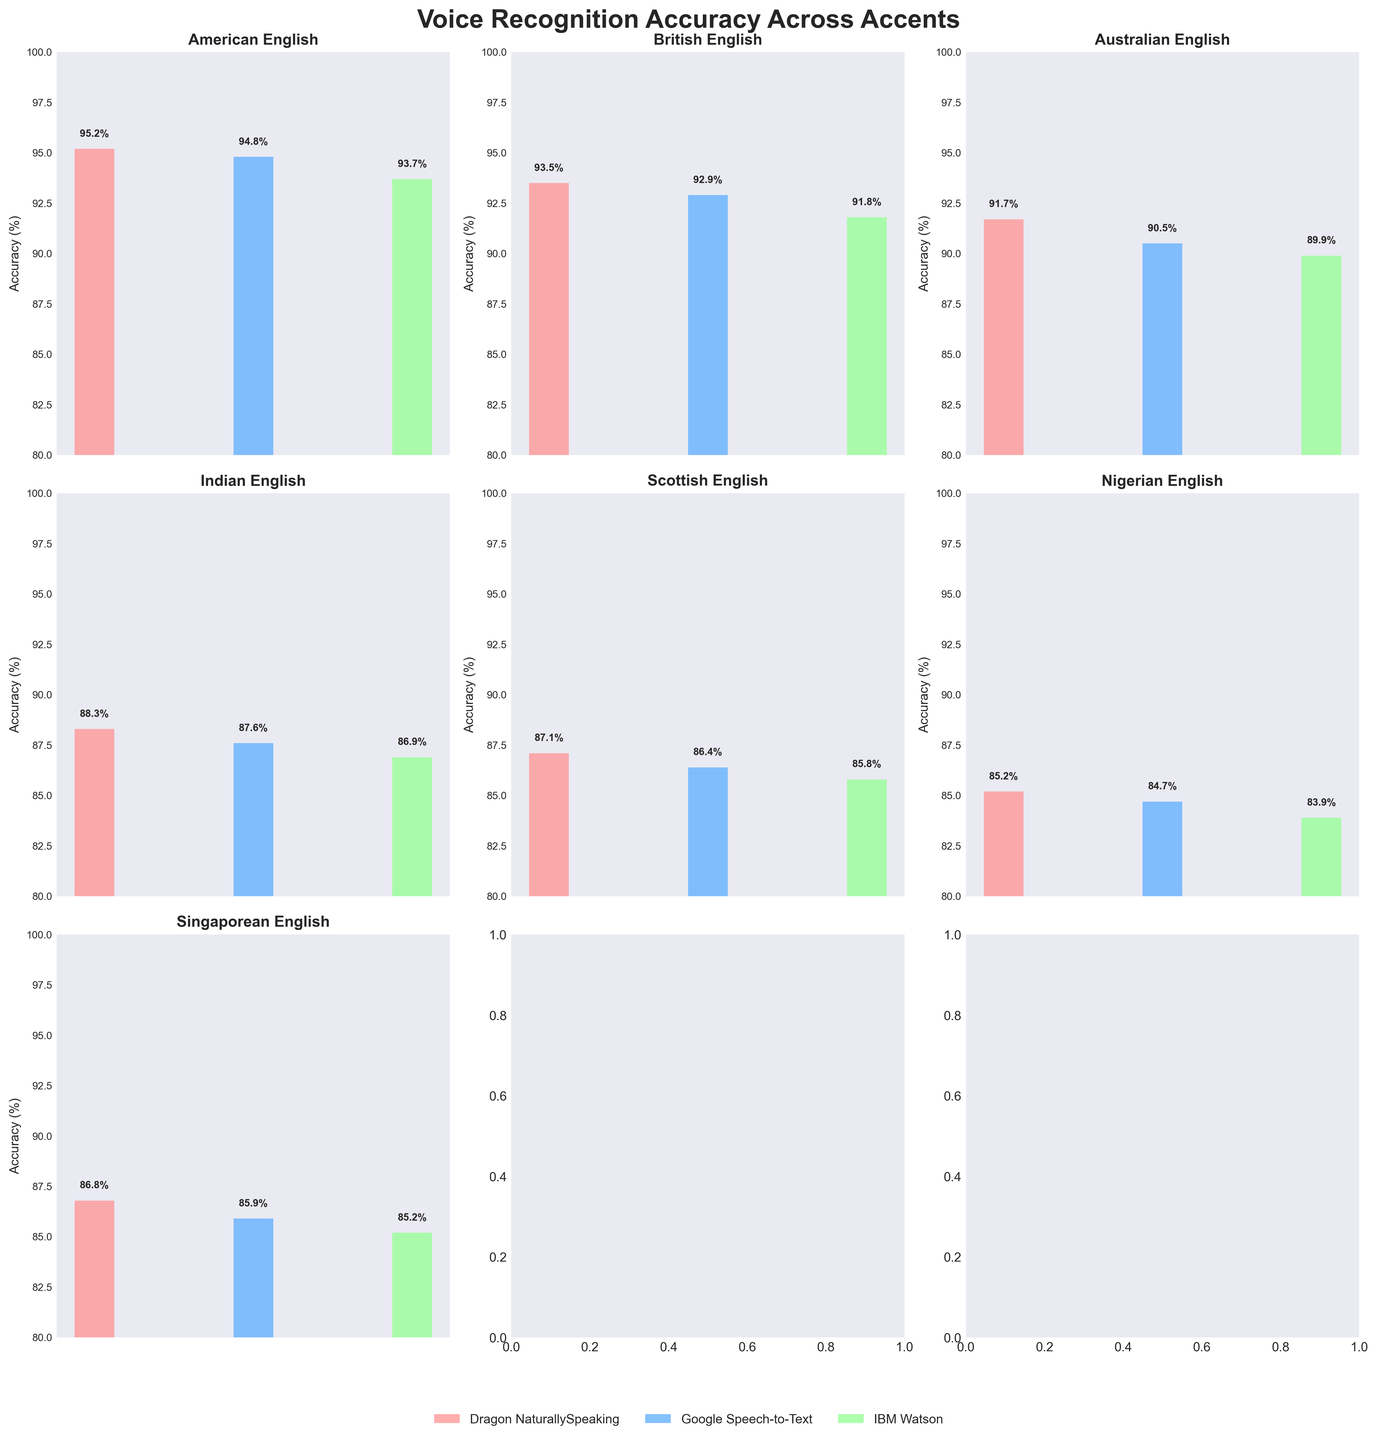Which accent shows the highest accuracy overall? By examining each subplot, the American English accent shows the highest accuracy, with all systems displaying high values, the highest being Dragon NaturallySpeaking with 95.2%.
Answer: American English Which system has the highest accuracy for British English? Looking at the British English subplot, Dragon NaturallySpeaking has the highest accuracy at 93.5%.
Answer: Dragon NaturallySpeaking How does Google's Speech-to-Text accuracy for Australian English compare to IBM Watson's for the same accent? In the Australian English subplot, Google's Speech-to-Text accuracy is 90.5%, while IBM Watson's accuracy is 89.9%. Google's Speech-to-Text is 0.6% higher.
Answer: Google's Speech-to-Text is higher What is the average accuracy of IBM Watson across all the accents? To calculate the average, we add IBM Watson's accuracy values for all accents (93.7 + 91.8 + 89.9 + 86.9 + 85.8 + 83.9 + 85.2) = 627.2 and divide by the number of accents (7), giving 627.2 / 7 ≈ 89.6.
Answer: ~89.6% Which accent shows the lowest accuracy for Google Speech-to-Text? By examining the Google Speech-to-Text bars across all subplots, the lowest value is for Nigerian English at 84.7%.
Answer: Nigerian English For the Indian English accent, what is the difference in accuracy between the highest and lowest performing systems? In the Indian English subplot, the highest accuracy is Dragon NaturallySpeaking at 88.3%, and the lowest is IBM Watson at 86.9%. The difference is 88.3% - 86.9% = 1.4%.
Answer: 1.4% Across all accents, which system shows the most consistent accuracy rates, and how do you determine this? To determine consistency, we look at the variability of accuracies within each system across all accents. Here, Dragon NaturallySpeaking shows relatively small differences in accuracy percentages across accents. One would subtract the lowest value from the highest: (95.2 - 85.2 = 10 for Dragon NaturallySpeaking), (94.8 - 84.7 = 10.1 for Google Speech-to-Text), and (93.7 - 83.9 = 9.8 for IBM Watson). IBM Watson shows the smallest range.
Answer: IBM Watson Between British English and Scottish English, which has a wider range of accuracy rates across the systems? For British English, the range is 93.5% (Dragon NaturallySpeaking) - 91.8% (IBM Watson) = 1.7%. For Scottish English, the range is 87.1% (Dragon NaturallySpeaking) - 85.8% (IBM Watson) = 1.3%. British English has a wider range.
Answer: British English 